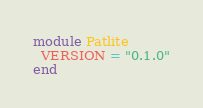Convert code to text. <code><loc_0><loc_0><loc_500><loc_500><_Crystal_>module Patlite
  VERSION = "0.1.0"
end
</code> 